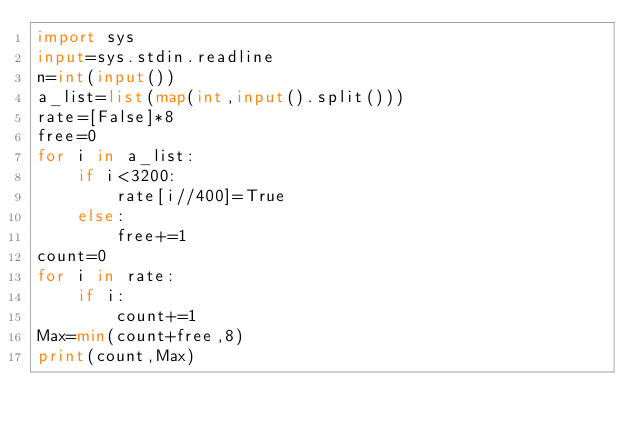<code> <loc_0><loc_0><loc_500><loc_500><_Python_>import sys
input=sys.stdin.readline
n=int(input())
a_list=list(map(int,input().split()))
rate=[False]*8
free=0
for i in a_list:
    if i<3200:
        rate[i//400]=True
    else:
        free+=1
count=0
for i in rate:
    if i:
        count+=1
Max=min(count+free,8)
print(count,Max)






</code> 